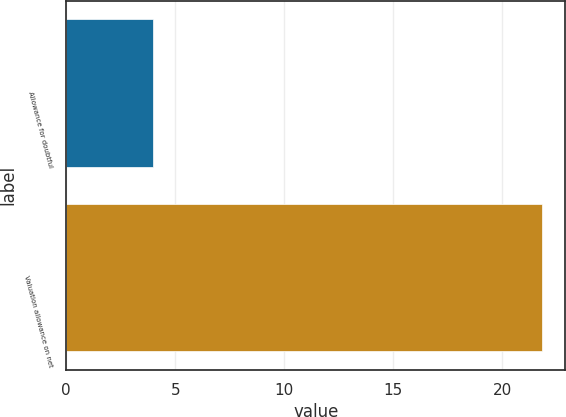Convert chart to OTSL. <chart><loc_0><loc_0><loc_500><loc_500><bar_chart><fcel>Allowance for doubtful<fcel>Valuation allowance on net<nl><fcel>4<fcel>21.8<nl></chart> 